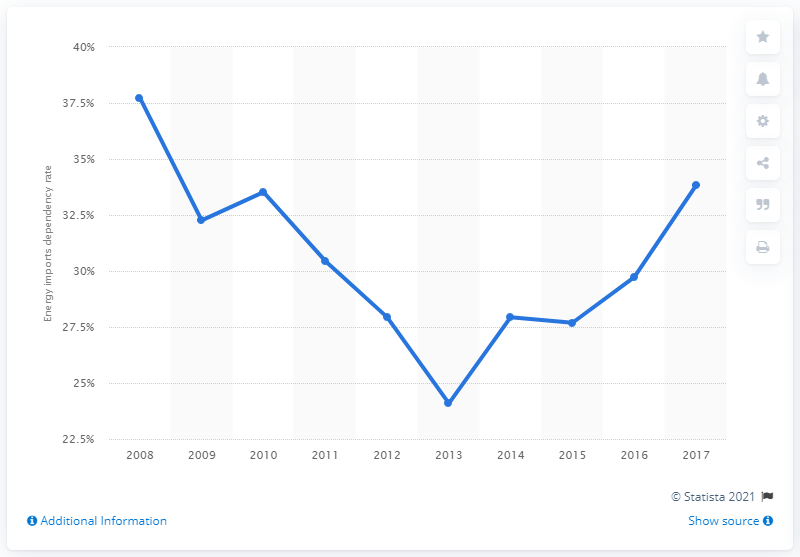Give some essential details in this illustration. In 2017, Serbia's dependency rate on energy imports was 33.82%. 